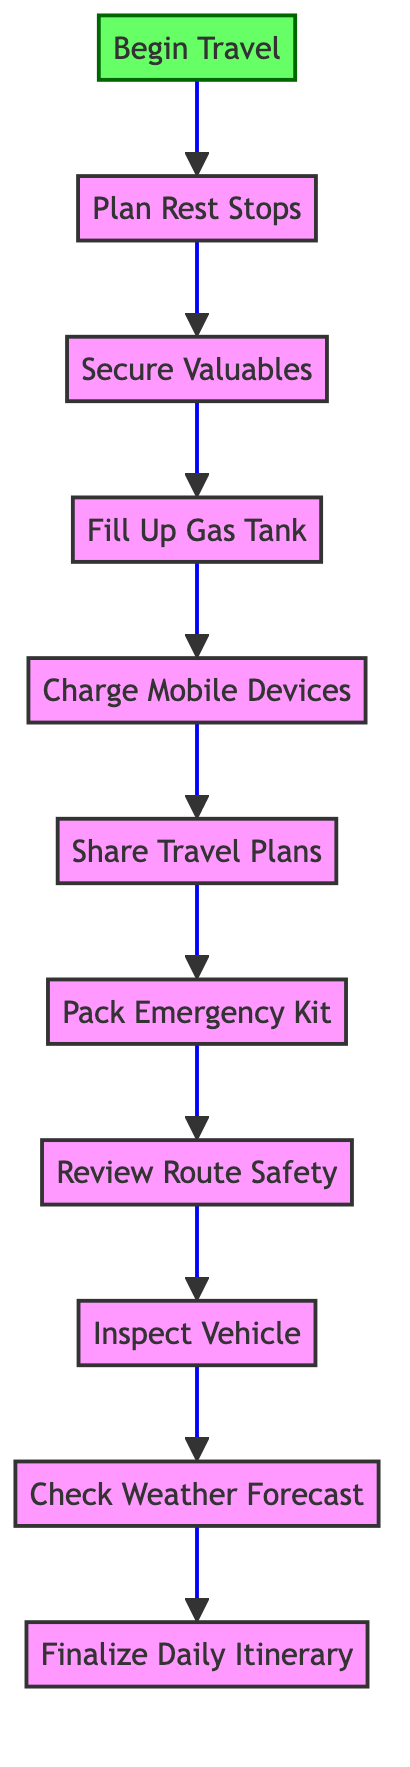What is the first step in the daily travel checklist? The first step, which is indicated at the bottom of the flowchart, is "Begin Travel."
Answer: Begin Travel How many steps are there in the checklist? By counting each node in the flowchart, there are a total of 11 steps from "Begin Travel" to "Finalize Daily Itinerary."
Answer: 11 What step comes before "Charge Mobile Devices"? The flowchart shows that the step that comes before "Charge Mobile Devices" is "Fill Up Gas Tank."
Answer: Fill Up Gas Tank What is the description of the "Inspect Vehicle" step? The description provided for "Inspect Vehicle" states, "Perform a basic check on your car, including tire pressure, oil levels, brakes, and fluid levels."
Answer: Perform a basic check on your car, including tire pressure, oil levels, brakes, and fluid levels What is the last step in the daily travel checklist? The last step, which is located at the top of the flowchart, is "Finalize Daily Itinerary."
Answer: Finalize Daily Itinerary Which step requires checking travel advisories? The step that specifically requires checking travel advisories is "Review Route Safety."
Answer: Review Route Safety If a person follows the steps sequentially, which step do they complete after "Pack Emergency Kit"? After completing "Pack Emergency Kit," the next step in the flowchart is "Review Route Safety."
Answer: Review Route Safety What is the relationship between "Secure Valuables" and "Charge Mobile Devices"? "Secure Valuables" is a step that comes before "Charge Mobile Devices," indicating a sequential relationship where one must be completed before the other.
Answer: Sequential relationship Which steps involve communication about travel plans? The steps that involve communication are "Share Travel Plans" and "Charge Mobile Devices," with "Share Travel Plans" specifically highlighting informing someone about the daily itinerary.
Answer: Share Travel Plans 